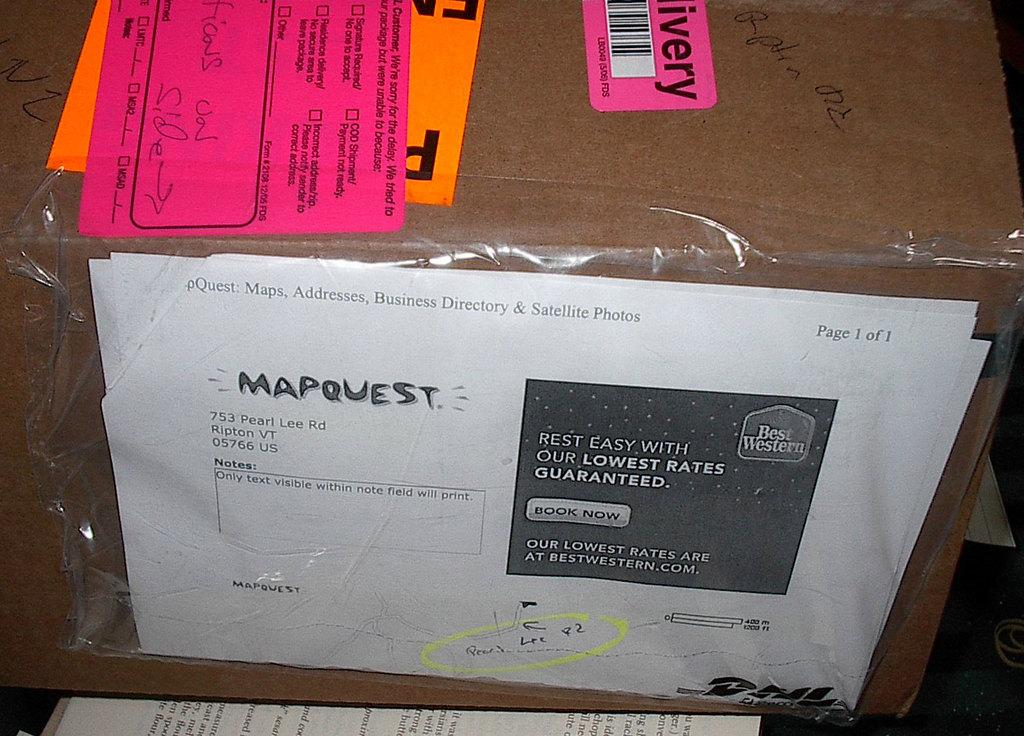<image>
Share a concise interpretation of the image provided. A box has a Mapquest printout attached to it. 